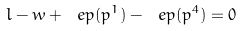Convert formula to latex. <formula><loc_0><loc_0><loc_500><loc_500>l - w + \ e p ( p ^ { 1 } ) - \ e p ( p ^ { 4 } ) = 0</formula> 